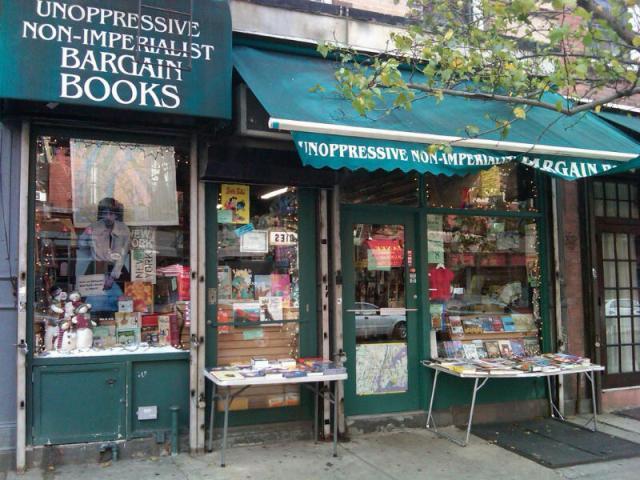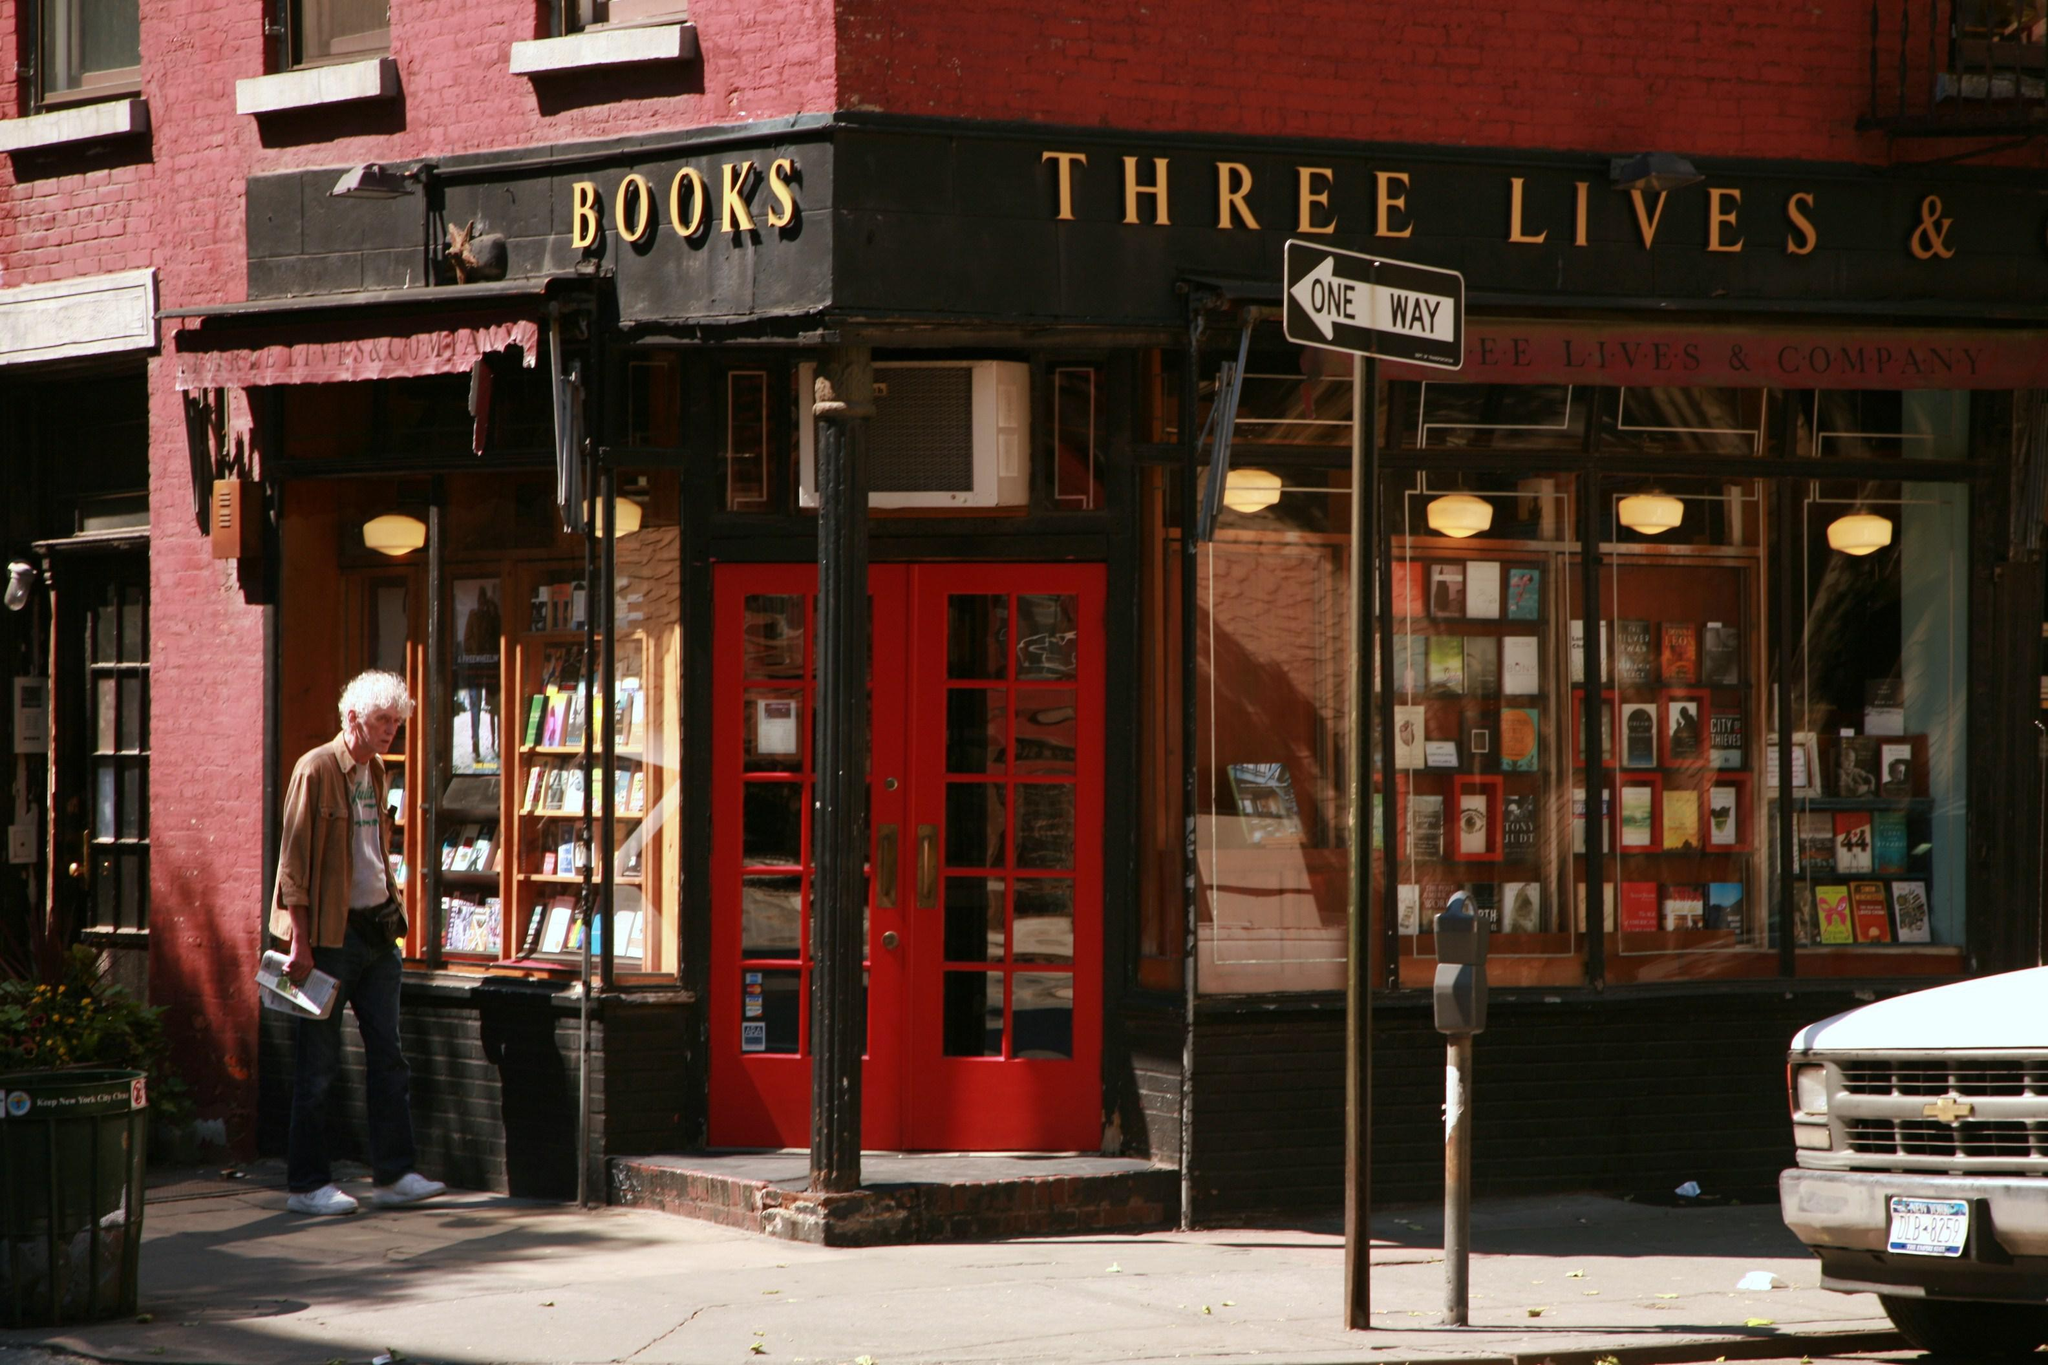The first image is the image on the left, the second image is the image on the right. For the images displayed, is the sentence "In one of the image a red door is open." factually correct? Answer yes or no. No. The first image is the image on the left, the second image is the image on the right. Considering the images on both sides, is "The store in the right image has a red door with multiple windows built into the door." valid? Answer yes or no. Yes. 